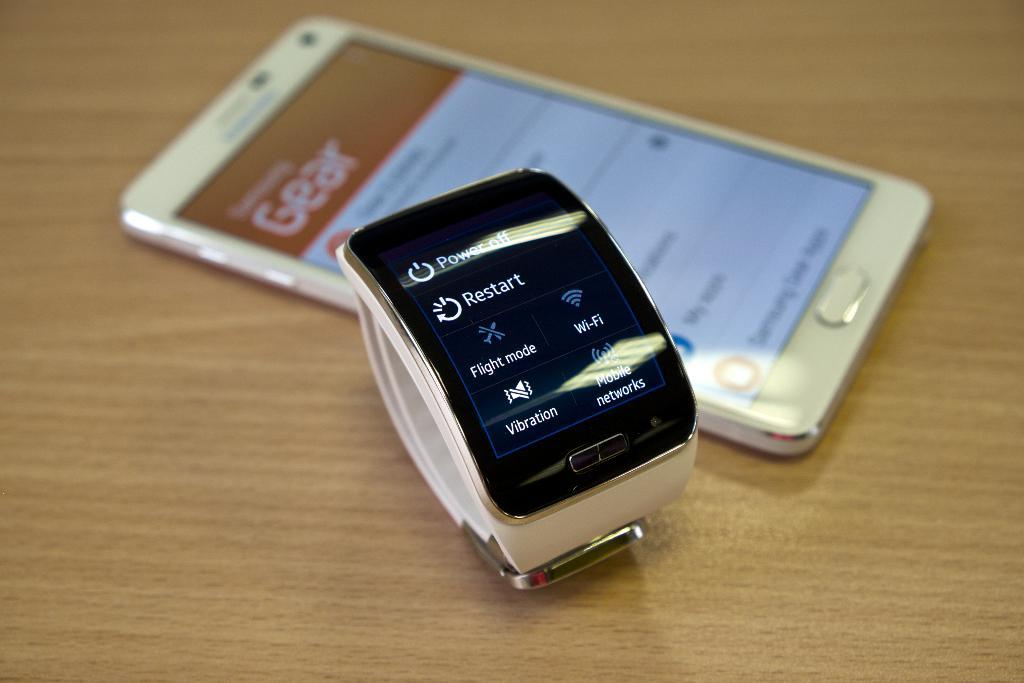Provide a one-sentence caption for the provided image. A s face showing selections on a smart watch like Restart. 